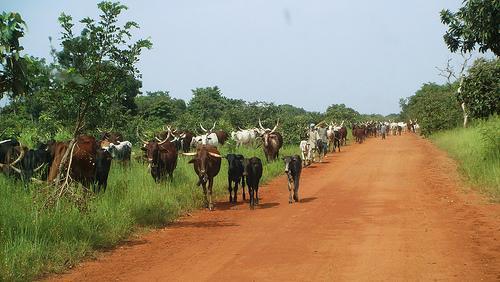How many cows are upfront on the road?
Give a very brief answer. 4. 